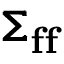<formula> <loc_0><loc_0><loc_500><loc_500>\pm b { \Sigma } _ { f f }</formula> 